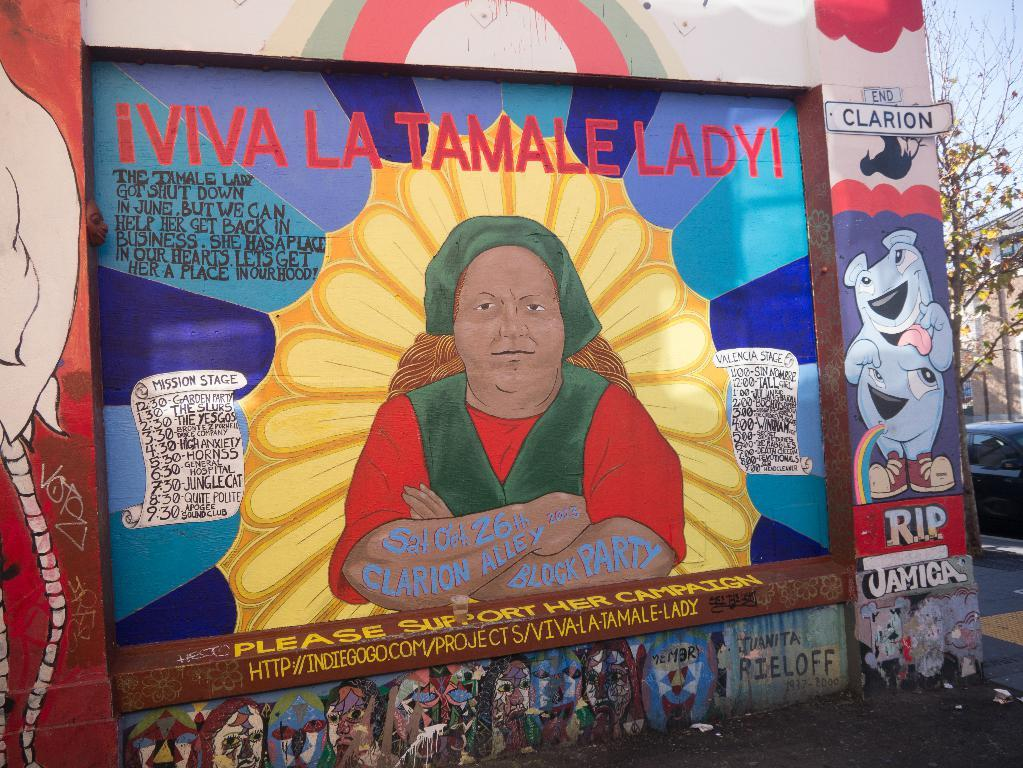What is depicted on the wall in the image? There is a wall with painting and text in the image. What can be seen on the left side of the image? There is a car and a tree on the left side of the image. What is visible in the background of the image? The sky is visible in the image. Is there a spy hiding behind the tree in the image? There is no indication of a spy or any hidden figures in the image; it only shows a car, a tree, and a wall with painting and text. What type of bead is used to create the painting on the wall? The image does not provide information about the materials used in the painting, so it is impossible to determine the type of bead used. 